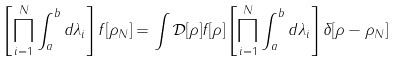Convert formula to latex. <formula><loc_0><loc_0><loc_500><loc_500>\left [ \prod _ { i = 1 } ^ { N } \int _ { a } ^ { b } d \lambda _ { i } \right ] f [ \rho _ { N } ] = \int \mathcal { D } [ \rho ] f [ \rho ] \left [ \prod _ { i = 1 } ^ { N } \int _ { a } ^ { b } d \lambda _ { i } \right ] \delta [ \rho - \rho _ { N } ]</formula> 